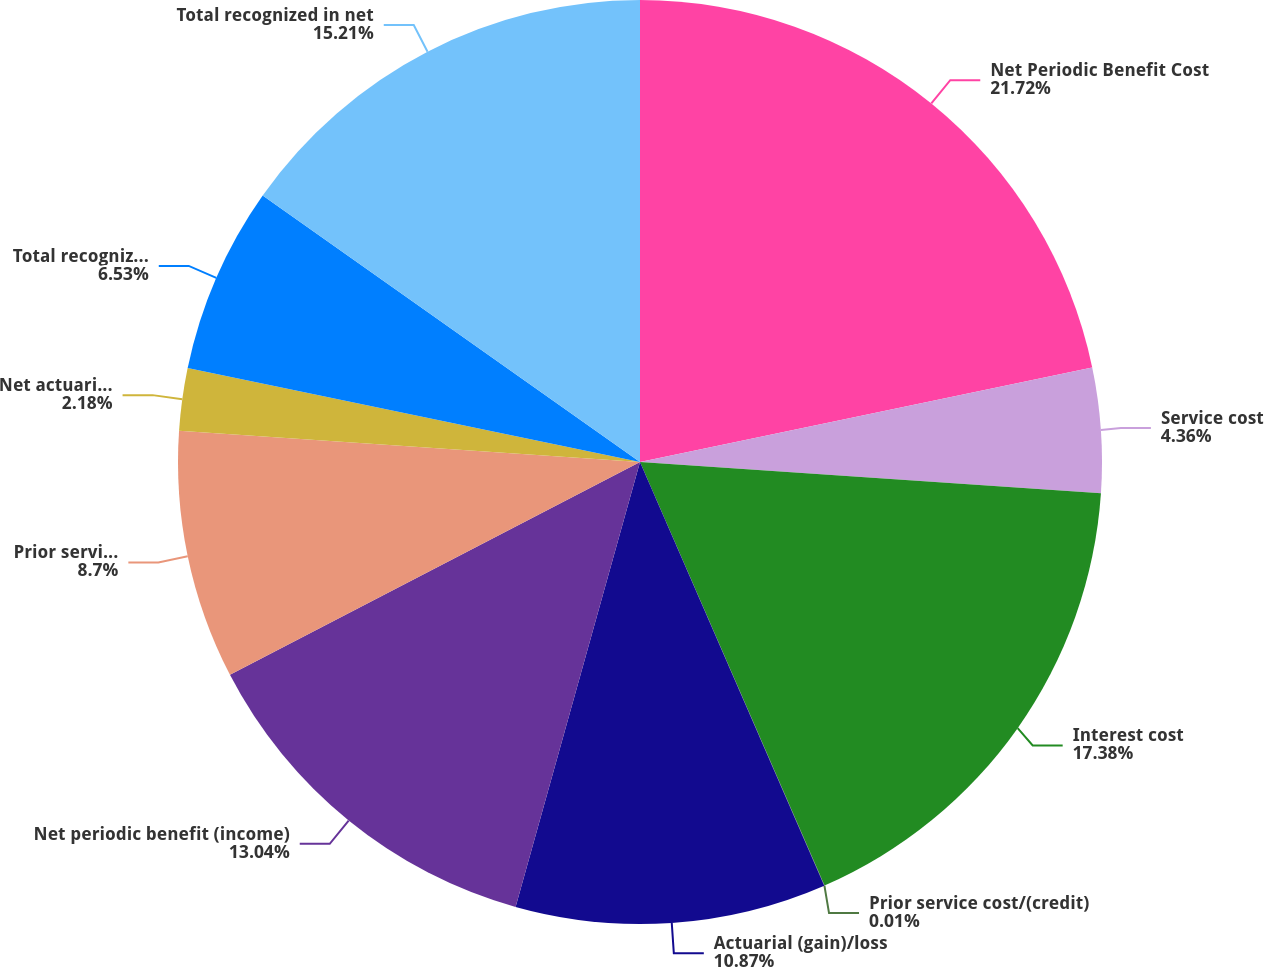Convert chart. <chart><loc_0><loc_0><loc_500><loc_500><pie_chart><fcel>Net Periodic Benefit Cost<fcel>Service cost<fcel>Interest cost<fcel>Prior service cost/(credit)<fcel>Actuarial (gain)/loss<fcel>Net periodic benefit (income)<fcel>Prior service cost (credit)<fcel>Net actuarial loss (gain)<fcel>Total recognized in other<fcel>Total recognized in net<nl><fcel>21.72%<fcel>4.36%<fcel>17.38%<fcel>0.01%<fcel>10.87%<fcel>13.04%<fcel>8.7%<fcel>2.18%<fcel>6.53%<fcel>15.21%<nl></chart> 